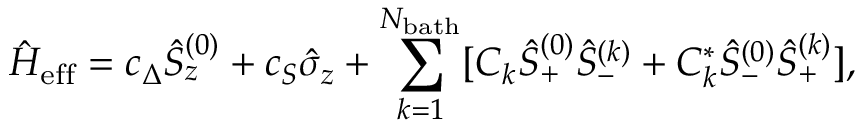<formula> <loc_0><loc_0><loc_500><loc_500>\hat { H } _ { e f f } = c _ { \Delta } \hat { S } _ { z } ^ { ( 0 ) } + c _ { S } \hat { \sigma } _ { z } + \sum _ { k = 1 } ^ { N _ { b a t h } } [ C _ { k } \hat { S } _ { + } ^ { ( 0 ) } \hat { S } _ { - } ^ { ( k ) } + C _ { k } ^ { * } \hat { S } _ { - } ^ { ( 0 ) } \hat { S } _ { + } ^ { ( k ) } ] ,</formula> 